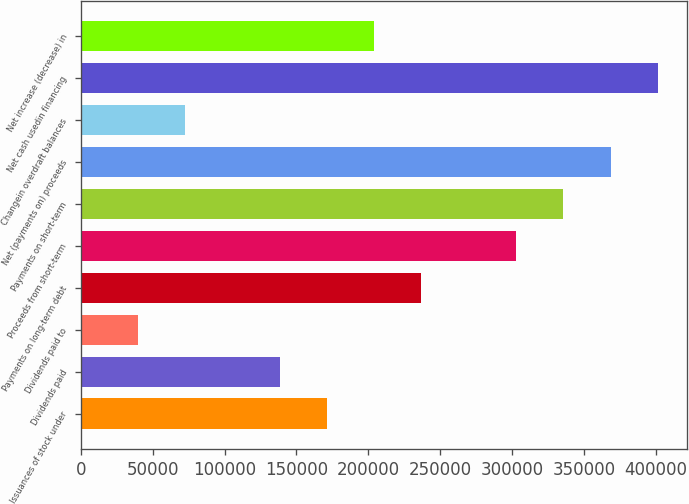Convert chart to OTSL. <chart><loc_0><loc_0><loc_500><loc_500><bar_chart><fcel>Issuances of stock under<fcel>Dividends paid<fcel>Dividends paid to<fcel>Payments on long-term debt<fcel>Proceeds from short-term<fcel>Payments on short-term<fcel>Net (payments on) proceeds<fcel>Changein overdraft balances<fcel>Net cash usedin financing<fcel>Net increase (decrease) in<nl><fcel>171220<fcel>138332<fcel>39665.7<fcel>236998<fcel>302775<fcel>335664<fcel>368553<fcel>72554.4<fcel>401441<fcel>204109<nl></chart> 